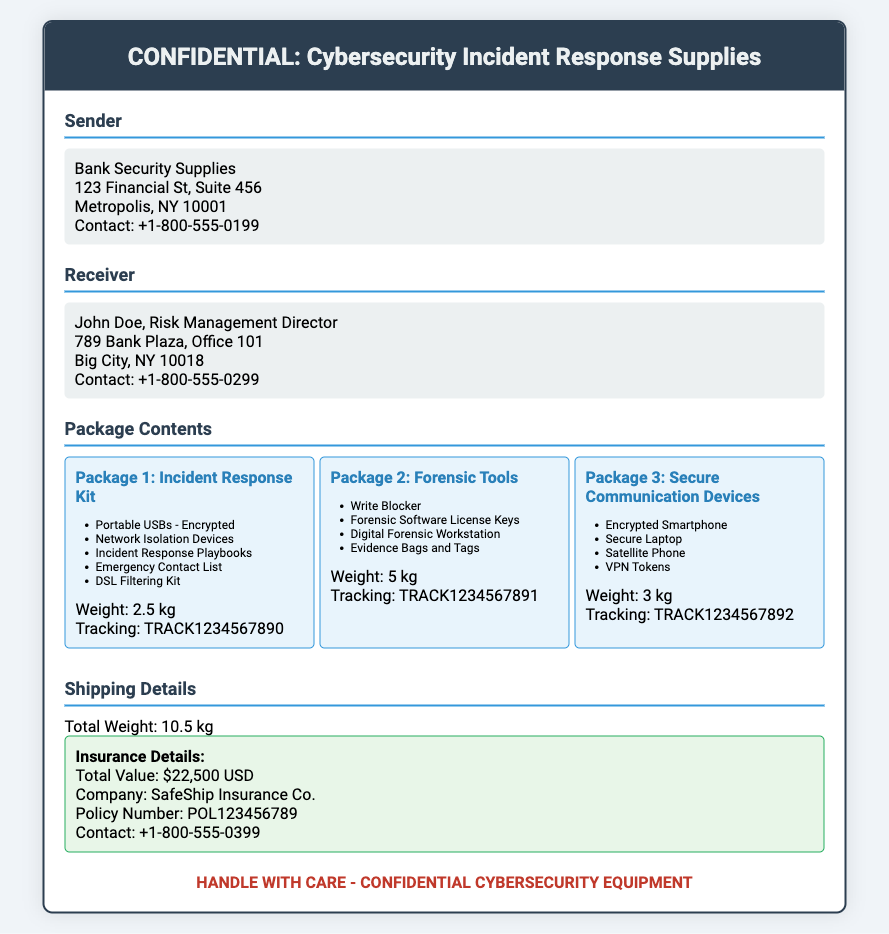What is the sender's contact number? The sender's contact number is listed as +1-800-555-0199 in the document.
Answer: +1-800-555-0199 What is the weight of Package 2? The weight of Package 2, which contains forensic tools, is given as 5 kg in the document.
Answer: 5 kg What is the total value insured? The total value insured is stated as $22,500 USD in the insurance details section.
Answer: $22,500 USD Who is the recipient? The recipient's name is John Doe, found in the receiver information section.
Answer: John Doe What type of item is included in Package 3? Package 3 contains secure communication devices, specifically listed items in the document.
Answer: Secure Communication Devices What is the policy number for shipping insurance? The policy number for the shipping insurance is POL123456789 as mentioned in the insurance details.
Answer: POL123456789 What is the total weight of all packages? The total weight of all packages is summarized as 10.5 kg in the shipping details section.
Answer: 10.5 kg How many items are listed in the Incident Response Kit? The Incident Response Kit includes five items listed in the document.
Answer: Five items What warning is displayed on the label? The warning displayed on the label states "HANDLE WITH CARE - CONFIDENTIAL CYBERSECURITY EQUIPMENT."
Answer: HANDLE WITH CARE - CONFIDENTIAL CYBERSECURITY EQUIPMENT 